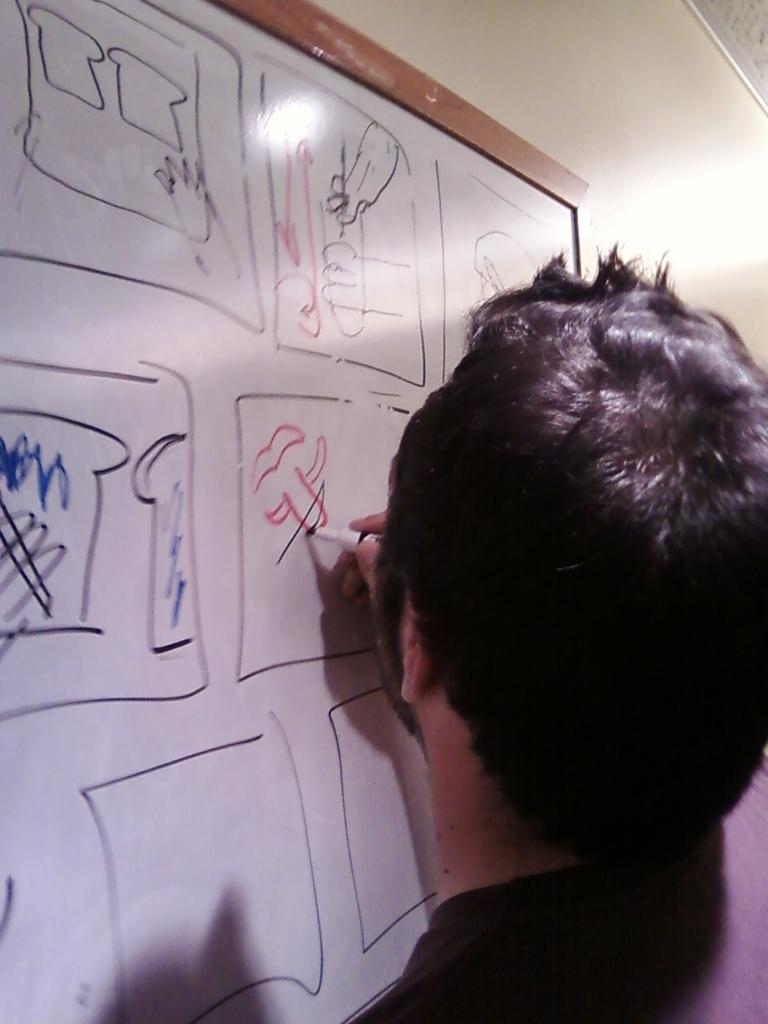What is the man in the image doing? The man is drawing something on a board. What is the man wearing in the image? The man is wearing a black T-shirt. What type of bone is the man holding in the image? There is no bone present in the image; the man is drawing on a board. 